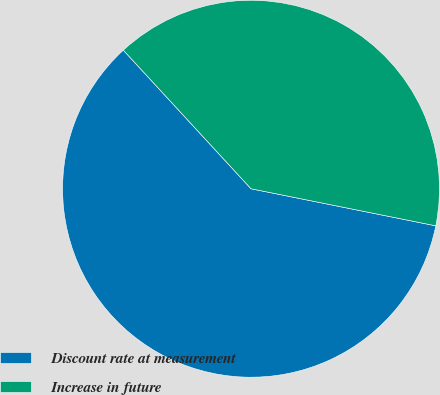Convert chart to OTSL. <chart><loc_0><loc_0><loc_500><loc_500><pie_chart><fcel>Discount rate at measurement<fcel>Increase in future<nl><fcel>60.0%<fcel>40.0%<nl></chart> 